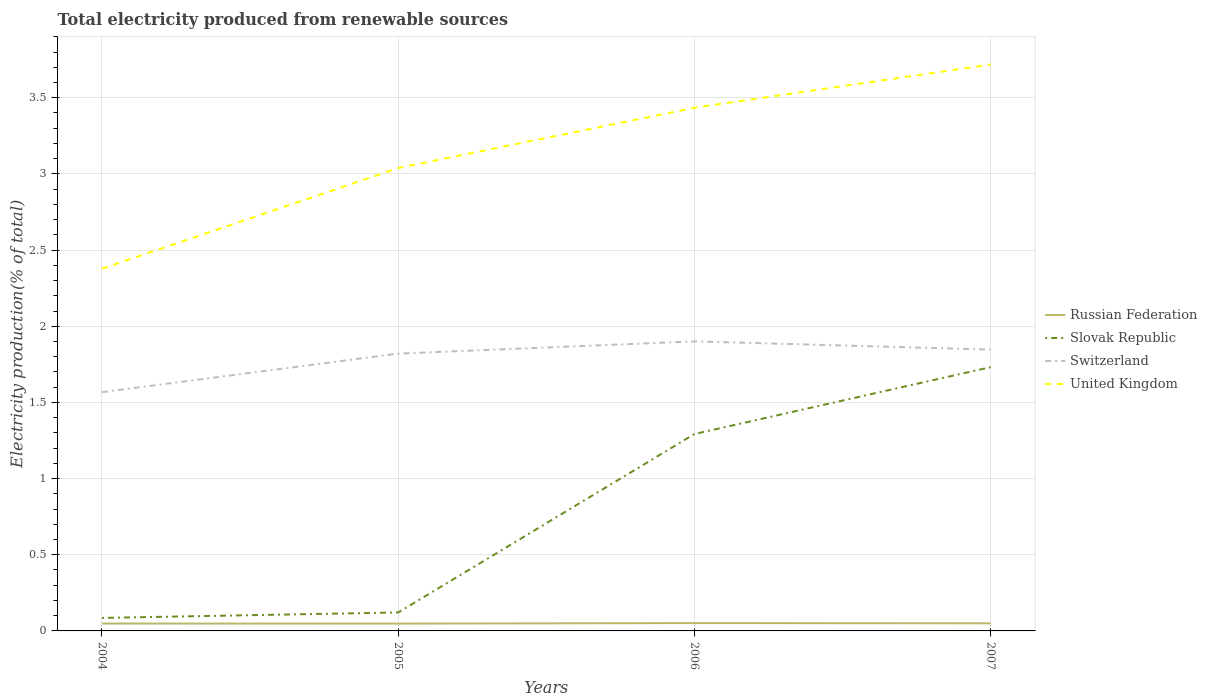How many different coloured lines are there?
Give a very brief answer. 4. Is the number of lines equal to the number of legend labels?
Offer a terse response. Yes. Across all years, what is the maximum total electricity produced in Switzerland?
Your answer should be very brief. 1.57. In which year was the total electricity produced in Russian Federation maximum?
Provide a succinct answer. 2005. What is the total total electricity produced in Russian Federation in the graph?
Ensure brevity in your answer.  -0. What is the difference between the highest and the second highest total electricity produced in Russian Federation?
Offer a terse response. 0. What is the difference between the highest and the lowest total electricity produced in United Kingdom?
Make the answer very short. 2. Is the total electricity produced in Russian Federation strictly greater than the total electricity produced in United Kingdom over the years?
Your answer should be compact. Yes. What is the difference between two consecutive major ticks on the Y-axis?
Offer a very short reply. 0.5. Are the values on the major ticks of Y-axis written in scientific E-notation?
Offer a terse response. No. Does the graph contain grids?
Provide a succinct answer. Yes. Where does the legend appear in the graph?
Provide a short and direct response. Center right. How are the legend labels stacked?
Ensure brevity in your answer.  Vertical. What is the title of the graph?
Make the answer very short. Total electricity produced from renewable sources. Does "Bahamas" appear as one of the legend labels in the graph?
Make the answer very short. No. What is the label or title of the X-axis?
Provide a succinct answer. Years. What is the Electricity production(% of total) in Russian Federation in 2004?
Your answer should be compact. 0.05. What is the Electricity production(% of total) of Slovak Republic in 2004?
Offer a very short reply. 0.09. What is the Electricity production(% of total) in Switzerland in 2004?
Ensure brevity in your answer.  1.57. What is the Electricity production(% of total) in United Kingdom in 2004?
Keep it short and to the point. 2.38. What is the Electricity production(% of total) of Russian Federation in 2005?
Your response must be concise. 0.05. What is the Electricity production(% of total) of Slovak Republic in 2005?
Offer a very short reply. 0.12. What is the Electricity production(% of total) of Switzerland in 2005?
Make the answer very short. 1.82. What is the Electricity production(% of total) of United Kingdom in 2005?
Keep it short and to the point. 3.04. What is the Electricity production(% of total) of Russian Federation in 2006?
Ensure brevity in your answer.  0.05. What is the Electricity production(% of total) of Slovak Republic in 2006?
Provide a succinct answer. 1.29. What is the Electricity production(% of total) of Switzerland in 2006?
Your answer should be very brief. 1.9. What is the Electricity production(% of total) of United Kingdom in 2006?
Your answer should be compact. 3.43. What is the Electricity production(% of total) of Russian Federation in 2007?
Provide a succinct answer. 0.05. What is the Electricity production(% of total) in Slovak Republic in 2007?
Your answer should be very brief. 1.73. What is the Electricity production(% of total) of Switzerland in 2007?
Offer a very short reply. 1.85. What is the Electricity production(% of total) in United Kingdom in 2007?
Ensure brevity in your answer.  3.72. Across all years, what is the maximum Electricity production(% of total) in Russian Federation?
Provide a short and direct response. 0.05. Across all years, what is the maximum Electricity production(% of total) in Slovak Republic?
Provide a short and direct response. 1.73. Across all years, what is the maximum Electricity production(% of total) in Switzerland?
Offer a very short reply. 1.9. Across all years, what is the maximum Electricity production(% of total) of United Kingdom?
Make the answer very short. 3.72. Across all years, what is the minimum Electricity production(% of total) of Russian Federation?
Make the answer very short. 0.05. Across all years, what is the minimum Electricity production(% of total) in Slovak Republic?
Offer a very short reply. 0.09. Across all years, what is the minimum Electricity production(% of total) of Switzerland?
Ensure brevity in your answer.  1.57. Across all years, what is the minimum Electricity production(% of total) of United Kingdom?
Your answer should be very brief. 2.38. What is the total Electricity production(% of total) in Russian Federation in the graph?
Offer a very short reply. 0.2. What is the total Electricity production(% of total) of Slovak Republic in the graph?
Ensure brevity in your answer.  3.23. What is the total Electricity production(% of total) of Switzerland in the graph?
Keep it short and to the point. 7.14. What is the total Electricity production(% of total) of United Kingdom in the graph?
Provide a succinct answer. 12.57. What is the difference between the Electricity production(% of total) of Slovak Republic in 2004 and that in 2005?
Ensure brevity in your answer.  -0.04. What is the difference between the Electricity production(% of total) of Switzerland in 2004 and that in 2005?
Your answer should be very brief. -0.25. What is the difference between the Electricity production(% of total) of United Kingdom in 2004 and that in 2005?
Make the answer very short. -0.66. What is the difference between the Electricity production(% of total) of Russian Federation in 2004 and that in 2006?
Offer a very short reply. -0. What is the difference between the Electricity production(% of total) of Slovak Republic in 2004 and that in 2006?
Offer a very short reply. -1.21. What is the difference between the Electricity production(% of total) of United Kingdom in 2004 and that in 2006?
Make the answer very short. -1.06. What is the difference between the Electricity production(% of total) in Russian Federation in 2004 and that in 2007?
Provide a succinct answer. -0. What is the difference between the Electricity production(% of total) in Slovak Republic in 2004 and that in 2007?
Your response must be concise. -1.65. What is the difference between the Electricity production(% of total) in Switzerland in 2004 and that in 2007?
Your response must be concise. -0.28. What is the difference between the Electricity production(% of total) of United Kingdom in 2004 and that in 2007?
Provide a short and direct response. -1.34. What is the difference between the Electricity production(% of total) in Russian Federation in 2005 and that in 2006?
Offer a very short reply. -0. What is the difference between the Electricity production(% of total) in Slovak Republic in 2005 and that in 2006?
Give a very brief answer. -1.17. What is the difference between the Electricity production(% of total) in Switzerland in 2005 and that in 2006?
Keep it short and to the point. -0.08. What is the difference between the Electricity production(% of total) of United Kingdom in 2005 and that in 2006?
Give a very brief answer. -0.4. What is the difference between the Electricity production(% of total) in Russian Federation in 2005 and that in 2007?
Your answer should be very brief. -0. What is the difference between the Electricity production(% of total) in Slovak Republic in 2005 and that in 2007?
Your response must be concise. -1.61. What is the difference between the Electricity production(% of total) in Switzerland in 2005 and that in 2007?
Your answer should be very brief. -0.03. What is the difference between the Electricity production(% of total) of United Kingdom in 2005 and that in 2007?
Your answer should be very brief. -0.68. What is the difference between the Electricity production(% of total) in Russian Federation in 2006 and that in 2007?
Ensure brevity in your answer.  0. What is the difference between the Electricity production(% of total) in Slovak Republic in 2006 and that in 2007?
Offer a terse response. -0.44. What is the difference between the Electricity production(% of total) in Switzerland in 2006 and that in 2007?
Offer a terse response. 0.05. What is the difference between the Electricity production(% of total) of United Kingdom in 2006 and that in 2007?
Give a very brief answer. -0.28. What is the difference between the Electricity production(% of total) of Russian Federation in 2004 and the Electricity production(% of total) of Slovak Republic in 2005?
Provide a short and direct response. -0.07. What is the difference between the Electricity production(% of total) of Russian Federation in 2004 and the Electricity production(% of total) of Switzerland in 2005?
Ensure brevity in your answer.  -1.77. What is the difference between the Electricity production(% of total) in Russian Federation in 2004 and the Electricity production(% of total) in United Kingdom in 2005?
Offer a terse response. -2.99. What is the difference between the Electricity production(% of total) in Slovak Republic in 2004 and the Electricity production(% of total) in Switzerland in 2005?
Provide a short and direct response. -1.74. What is the difference between the Electricity production(% of total) in Slovak Republic in 2004 and the Electricity production(% of total) in United Kingdom in 2005?
Keep it short and to the point. -2.95. What is the difference between the Electricity production(% of total) of Switzerland in 2004 and the Electricity production(% of total) of United Kingdom in 2005?
Your answer should be very brief. -1.47. What is the difference between the Electricity production(% of total) of Russian Federation in 2004 and the Electricity production(% of total) of Slovak Republic in 2006?
Provide a short and direct response. -1.24. What is the difference between the Electricity production(% of total) in Russian Federation in 2004 and the Electricity production(% of total) in Switzerland in 2006?
Offer a very short reply. -1.85. What is the difference between the Electricity production(% of total) of Russian Federation in 2004 and the Electricity production(% of total) of United Kingdom in 2006?
Provide a succinct answer. -3.39. What is the difference between the Electricity production(% of total) in Slovak Republic in 2004 and the Electricity production(% of total) in Switzerland in 2006?
Provide a succinct answer. -1.82. What is the difference between the Electricity production(% of total) in Slovak Republic in 2004 and the Electricity production(% of total) in United Kingdom in 2006?
Your response must be concise. -3.35. What is the difference between the Electricity production(% of total) of Switzerland in 2004 and the Electricity production(% of total) of United Kingdom in 2006?
Your answer should be very brief. -1.87. What is the difference between the Electricity production(% of total) of Russian Federation in 2004 and the Electricity production(% of total) of Slovak Republic in 2007?
Your response must be concise. -1.68. What is the difference between the Electricity production(% of total) of Russian Federation in 2004 and the Electricity production(% of total) of Switzerland in 2007?
Your answer should be compact. -1.8. What is the difference between the Electricity production(% of total) in Russian Federation in 2004 and the Electricity production(% of total) in United Kingdom in 2007?
Your answer should be very brief. -3.67. What is the difference between the Electricity production(% of total) in Slovak Republic in 2004 and the Electricity production(% of total) in Switzerland in 2007?
Keep it short and to the point. -1.76. What is the difference between the Electricity production(% of total) in Slovak Republic in 2004 and the Electricity production(% of total) in United Kingdom in 2007?
Your answer should be very brief. -3.63. What is the difference between the Electricity production(% of total) in Switzerland in 2004 and the Electricity production(% of total) in United Kingdom in 2007?
Provide a short and direct response. -2.15. What is the difference between the Electricity production(% of total) of Russian Federation in 2005 and the Electricity production(% of total) of Slovak Republic in 2006?
Make the answer very short. -1.24. What is the difference between the Electricity production(% of total) in Russian Federation in 2005 and the Electricity production(% of total) in Switzerland in 2006?
Keep it short and to the point. -1.85. What is the difference between the Electricity production(% of total) in Russian Federation in 2005 and the Electricity production(% of total) in United Kingdom in 2006?
Provide a succinct answer. -3.39. What is the difference between the Electricity production(% of total) in Slovak Republic in 2005 and the Electricity production(% of total) in Switzerland in 2006?
Offer a very short reply. -1.78. What is the difference between the Electricity production(% of total) of Slovak Republic in 2005 and the Electricity production(% of total) of United Kingdom in 2006?
Keep it short and to the point. -3.31. What is the difference between the Electricity production(% of total) of Switzerland in 2005 and the Electricity production(% of total) of United Kingdom in 2006?
Your response must be concise. -1.61. What is the difference between the Electricity production(% of total) in Russian Federation in 2005 and the Electricity production(% of total) in Slovak Republic in 2007?
Your response must be concise. -1.68. What is the difference between the Electricity production(% of total) in Russian Federation in 2005 and the Electricity production(% of total) in Switzerland in 2007?
Your answer should be very brief. -1.8. What is the difference between the Electricity production(% of total) of Russian Federation in 2005 and the Electricity production(% of total) of United Kingdom in 2007?
Give a very brief answer. -3.67. What is the difference between the Electricity production(% of total) of Slovak Republic in 2005 and the Electricity production(% of total) of Switzerland in 2007?
Provide a short and direct response. -1.73. What is the difference between the Electricity production(% of total) of Slovak Republic in 2005 and the Electricity production(% of total) of United Kingdom in 2007?
Your answer should be compact. -3.6. What is the difference between the Electricity production(% of total) in Switzerland in 2005 and the Electricity production(% of total) in United Kingdom in 2007?
Offer a very short reply. -1.9. What is the difference between the Electricity production(% of total) of Russian Federation in 2006 and the Electricity production(% of total) of Slovak Republic in 2007?
Ensure brevity in your answer.  -1.68. What is the difference between the Electricity production(% of total) in Russian Federation in 2006 and the Electricity production(% of total) in Switzerland in 2007?
Your response must be concise. -1.8. What is the difference between the Electricity production(% of total) of Russian Federation in 2006 and the Electricity production(% of total) of United Kingdom in 2007?
Offer a terse response. -3.67. What is the difference between the Electricity production(% of total) of Slovak Republic in 2006 and the Electricity production(% of total) of Switzerland in 2007?
Provide a succinct answer. -0.55. What is the difference between the Electricity production(% of total) in Slovak Republic in 2006 and the Electricity production(% of total) in United Kingdom in 2007?
Your response must be concise. -2.43. What is the difference between the Electricity production(% of total) of Switzerland in 2006 and the Electricity production(% of total) of United Kingdom in 2007?
Your answer should be compact. -1.82. What is the average Electricity production(% of total) of Russian Federation per year?
Offer a terse response. 0.05. What is the average Electricity production(% of total) in Slovak Republic per year?
Your response must be concise. 0.81. What is the average Electricity production(% of total) in Switzerland per year?
Ensure brevity in your answer.  1.78. What is the average Electricity production(% of total) of United Kingdom per year?
Provide a short and direct response. 3.14. In the year 2004, what is the difference between the Electricity production(% of total) in Russian Federation and Electricity production(% of total) in Slovak Republic?
Ensure brevity in your answer.  -0.04. In the year 2004, what is the difference between the Electricity production(% of total) in Russian Federation and Electricity production(% of total) in Switzerland?
Make the answer very short. -1.52. In the year 2004, what is the difference between the Electricity production(% of total) in Russian Federation and Electricity production(% of total) in United Kingdom?
Keep it short and to the point. -2.33. In the year 2004, what is the difference between the Electricity production(% of total) in Slovak Republic and Electricity production(% of total) in Switzerland?
Your response must be concise. -1.48. In the year 2004, what is the difference between the Electricity production(% of total) of Slovak Republic and Electricity production(% of total) of United Kingdom?
Keep it short and to the point. -2.29. In the year 2004, what is the difference between the Electricity production(% of total) in Switzerland and Electricity production(% of total) in United Kingdom?
Ensure brevity in your answer.  -0.81. In the year 2005, what is the difference between the Electricity production(% of total) of Russian Federation and Electricity production(% of total) of Slovak Republic?
Provide a succinct answer. -0.07. In the year 2005, what is the difference between the Electricity production(% of total) in Russian Federation and Electricity production(% of total) in Switzerland?
Provide a succinct answer. -1.77. In the year 2005, what is the difference between the Electricity production(% of total) in Russian Federation and Electricity production(% of total) in United Kingdom?
Offer a terse response. -2.99. In the year 2005, what is the difference between the Electricity production(% of total) in Slovak Republic and Electricity production(% of total) in Switzerland?
Keep it short and to the point. -1.7. In the year 2005, what is the difference between the Electricity production(% of total) of Slovak Republic and Electricity production(% of total) of United Kingdom?
Your response must be concise. -2.92. In the year 2005, what is the difference between the Electricity production(% of total) in Switzerland and Electricity production(% of total) in United Kingdom?
Offer a very short reply. -1.22. In the year 2006, what is the difference between the Electricity production(% of total) in Russian Federation and Electricity production(% of total) in Slovak Republic?
Give a very brief answer. -1.24. In the year 2006, what is the difference between the Electricity production(% of total) of Russian Federation and Electricity production(% of total) of Switzerland?
Provide a succinct answer. -1.85. In the year 2006, what is the difference between the Electricity production(% of total) of Russian Federation and Electricity production(% of total) of United Kingdom?
Provide a short and direct response. -3.38. In the year 2006, what is the difference between the Electricity production(% of total) in Slovak Republic and Electricity production(% of total) in Switzerland?
Your answer should be compact. -0.61. In the year 2006, what is the difference between the Electricity production(% of total) of Slovak Republic and Electricity production(% of total) of United Kingdom?
Offer a very short reply. -2.14. In the year 2006, what is the difference between the Electricity production(% of total) in Switzerland and Electricity production(% of total) in United Kingdom?
Provide a short and direct response. -1.53. In the year 2007, what is the difference between the Electricity production(% of total) in Russian Federation and Electricity production(% of total) in Slovak Republic?
Make the answer very short. -1.68. In the year 2007, what is the difference between the Electricity production(% of total) of Russian Federation and Electricity production(% of total) of Switzerland?
Offer a terse response. -1.8. In the year 2007, what is the difference between the Electricity production(% of total) of Russian Federation and Electricity production(% of total) of United Kingdom?
Your answer should be very brief. -3.67. In the year 2007, what is the difference between the Electricity production(% of total) of Slovak Republic and Electricity production(% of total) of Switzerland?
Offer a terse response. -0.12. In the year 2007, what is the difference between the Electricity production(% of total) in Slovak Republic and Electricity production(% of total) in United Kingdom?
Your response must be concise. -1.99. In the year 2007, what is the difference between the Electricity production(% of total) in Switzerland and Electricity production(% of total) in United Kingdom?
Offer a terse response. -1.87. What is the ratio of the Electricity production(% of total) of Russian Federation in 2004 to that in 2005?
Give a very brief answer. 1.01. What is the ratio of the Electricity production(% of total) of Slovak Republic in 2004 to that in 2005?
Offer a terse response. 0.7. What is the ratio of the Electricity production(% of total) of Switzerland in 2004 to that in 2005?
Your answer should be compact. 0.86. What is the ratio of the Electricity production(% of total) of United Kingdom in 2004 to that in 2005?
Provide a short and direct response. 0.78. What is the ratio of the Electricity production(% of total) of Russian Federation in 2004 to that in 2006?
Keep it short and to the point. 0.94. What is the ratio of the Electricity production(% of total) in Slovak Republic in 2004 to that in 2006?
Offer a very short reply. 0.07. What is the ratio of the Electricity production(% of total) in Switzerland in 2004 to that in 2006?
Give a very brief answer. 0.82. What is the ratio of the Electricity production(% of total) of United Kingdom in 2004 to that in 2006?
Ensure brevity in your answer.  0.69. What is the ratio of the Electricity production(% of total) of Russian Federation in 2004 to that in 2007?
Provide a short and direct response. 0.97. What is the ratio of the Electricity production(% of total) in Slovak Republic in 2004 to that in 2007?
Provide a succinct answer. 0.05. What is the ratio of the Electricity production(% of total) of Switzerland in 2004 to that in 2007?
Provide a short and direct response. 0.85. What is the ratio of the Electricity production(% of total) of United Kingdom in 2004 to that in 2007?
Keep it short and to the point. 0.64. What is the ratio of the Electricity production(% of total) in Russian Federation in 2005 to that in 2006?
Provide a short and direct response. 0.93. What is the ratio of the Electricity production(% of total) in Slovak Republic in 2005 to that in 2006?
Offer a very short reply. 0.09. What is the ratio of the Electricity production(% of total) of Switzerland in 2005 to that in 2006?
Keep it short and to the point. 0.96. What is the ratio of the Electricity production(% of total) in United Kingdom in 2005 to that in 2006?
Keep it short and to the point. 0.88. What is the ratio of the Electricity production(% of total) of Russian Federation in 2005 to that in 2007?
Your answer should be very brief. 0.96. What is the ratio of the Electricity production(% of total) of Slovak Republic in 2005 to that in 2007?
Keep it short and to the point. 0.07. What is the ratio of the Electricity production(% of total) of Switzerland in 2005 to that in 2007?
Ensure brevity in your answer.  0.99. What is the ratio of the Electricity production(% of total) in United Kingdom in 2005 to that in 2007?
Your response must be concise. 0.82. What is the ratio of the Electricity production(% of total) in Russian Federation in 2006 to that in 2007?
Your response must be concise. 1.03. What is the ratio of the Electricity production(% of total) in Slovak Republic in 2006 to that in 2007?
Give a very brief answer. 0.75. What is the ratio of the Electricity production(% of total) of Switzerland in 2006 to that in 2007?
Offer a terse response. 1.03. What is the ratio of the Electricity production(% of total) of United Kingdom in 2006 to that in 2007?
Make the answer very short. 0.92. What is the difference between the highest and the second highest Electricity production(% of total) of Russian Federation?
Offer a very short reply. 0. What is the difference between the highest and the second highest Electricity production(% of total) of Slovak Republic?
Ensure brevity in your answer.  0.44. What is the difference between the highest and the second highest Electricity production(% of total) of Switzerland?
Your answer should be compact. 0.05. What is the difference between the highest and the second highest Electricity production(% of total) in United Kingdom?
Your answer should be very brief. 0.28. What is the difference between the highest and the lowest Electricity production(% of total) in Russian Federation?
Provide a succinct answer. 0. What is the difference between the highest and the lowest Electricity production(% of total) in Slovak Republic?
Offer a very short reply. 1.65. What is the difference between the highest and the lowest Electricity production(% of total) of Switzerland?
Keep it short and to the point. 0.33. What is the difference between the highest and the lowest Electricity production(% of total) in United Kingdom?
Give a very brief answer. 1.34. 